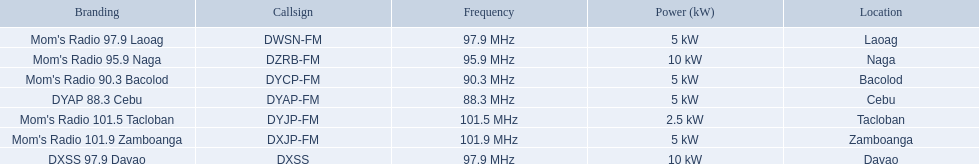What brands possess a 5 kw power rating? Mom's Radio 97.9 Laoag, Mom's Radio 90.3 Bacolod, DYAP 88.3 Cebu, Mom's Radio 101.9 Zamboanga. From those, which has a call-sign that starts with dy? Mom's Radio 90.3 Bacolod, DYAP 88.3 Cebu. Among these, which one utilizes the lowest frequency? DYAP 88.3 Cebu. 